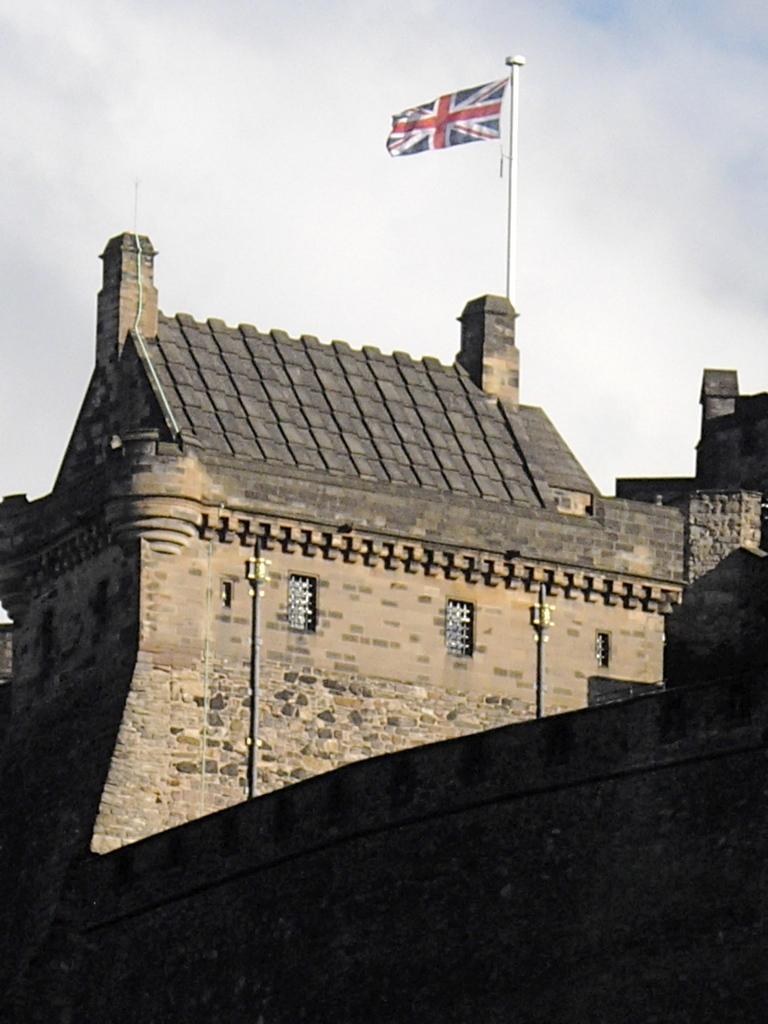Describe this image in one or two sentences. In this image we can see a building, windows, poles, flag, also we can see the wall, and the sky. 